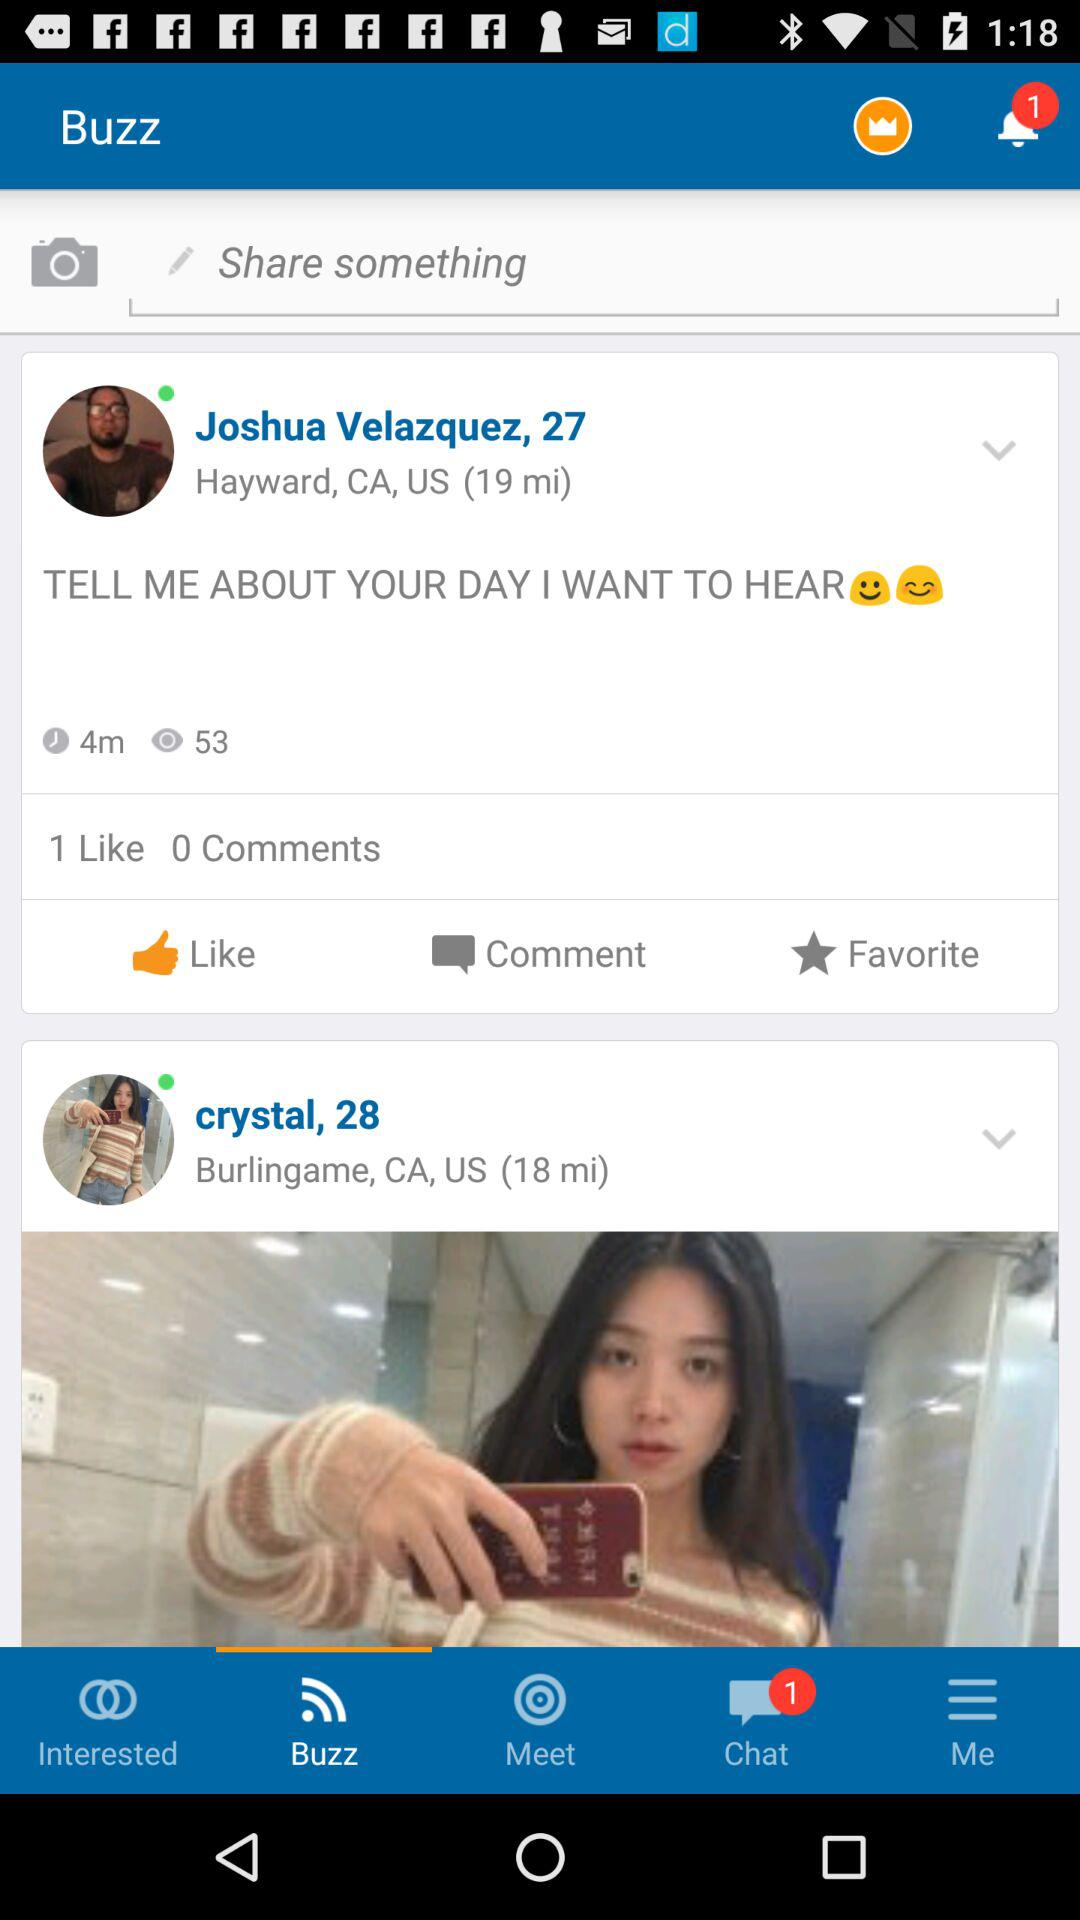Which tab is selected? The selected tab is "Buzz". 